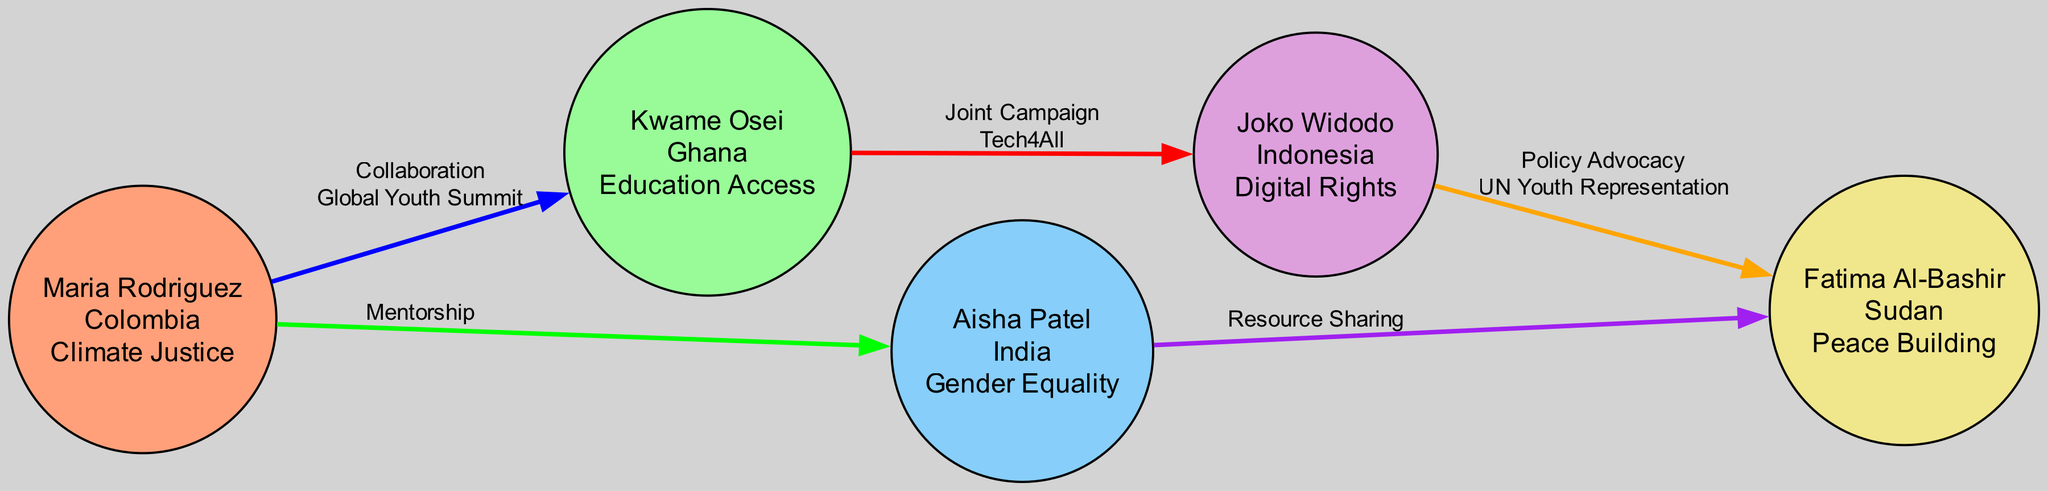What is the total number of youth leaders depicted in the diagram? The diagram includes a list of nodes representing each youth leader. By counting each unique node in the "nodes" section of the data, we find there are five distinct youth leaders.
Answer: 5 Which country is Fatima Al-Bashir from? Looking at the node for Fatima Al-Bashir, we see that her country is specified directly. Thus, we can state the country associated with her node.
Answer: Sudan What type of connection exists between Maria Rodriguez and Aisha Patel? To determine the type of connection between these two nodes, we review the edges connecting them. The edge between their nodes indicates a "Mentorship" relationship, identifying the nature of their link.
Answer: Mentorship How many types of connections are illustrated in the diagram? The types of connections can be found by examining the various edges. Each unique type that connects nodes is considered. In this diagram, we count five distinct types of connections: Collaboration, Mentorship, Joint Campaign, Resource Sharing, and Policy Advocacy.
Answer: 5 Which campaign is associated with the connection between Kwame Osei and Joko Widodo? By checking the edge that connects these two youth leaders, we find that it specifies a "Joint Campaign," and further details it as "Tech4All." Therefore, the specific campaign relating to their connection is noted.
Answer: Tech4All Who is involved in the Resource Sharing connection? This connection can be traced by reviewing the edge that indicates Resource Sharing. The two nodes connected by this edge are Aisha Patel and Fatima Al-Bashir. Therefore, both individuals actively participate in this particular connection.
Answer: Aisha Patel and Fatima Al-Bashir Which youth leader focuses on Digital Rights? To answer this, we look at the node corresponding to Joko Widodo, which directly states that his focus area is Digital Rights. Therefore, the specific youth leader associated with this focus can be identified.
Answer: Joko Widodo What is the color representing Ghana on the diagram? Each country in the diagram is assigned a specific color. The node for Kwame Osei, who is from Ghana, uses the color green. This color coding helps associate the visual aspect with the respective countries.
Answer: Green 